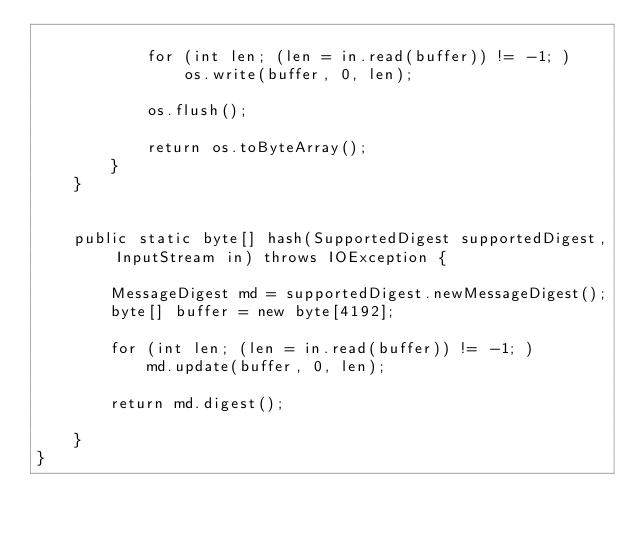<code> <loc_0><loc_0><loc_500><loc_500><_Java_>
            for (int len; (len = in.read(buffer)) != -1; )
                os.write(buffer, 0, len);

            os.flush();

            return os.toByteArray();
        }
    }


    public static byte[] hash(SupportedDigest supportedDigest, InputStream in) throws IOException {

        MessageDigest md = supportedDigest.newMessageDigest();
        byte[] buffer = new byte[4192];

        for (int len; (len = in.read(buffer)) != -1; )
            md.update(buffer, 0, len);

        return md.digest();

    }
}
</code> 